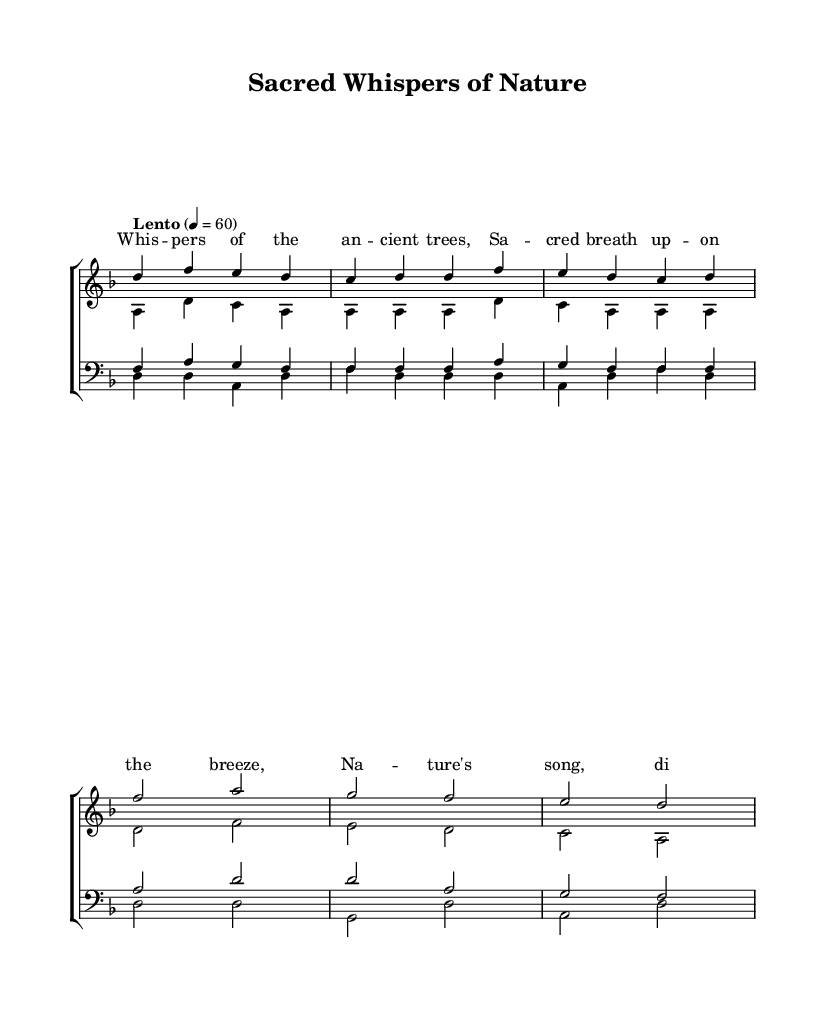What is the key signature of this music? The key signature is indicated at the beginning of the piece as D minor, which has one flat.
Answer: D minor What is the time signature of this music? The time signature is located at the beginning, depicted as 4/4, which means there are four beats in each measure.
Answer: 4/4 What is the tempo marking for this piece? The tempo marking is found near the beginning as "Lento," which signifies a slow pace, with a metronome indication of 60 beats per minute.
Answer: Lento How many parts are there in this choir arrangement? By examining the score, there are four main vocal parts: sopranos, altos, tenors, and basses, which create a rich choral texture.
Answer: Four What words are sung in the chorus section? The words for the chorus are visually discernible in the lyrics section aligned with the chorus melody, which states "Nature's song, divine and free."
Answer: Nature's song, divine and free Which musical element blends with the choral components in this piece? The sheet music indicates that natural sounds blend with the choral elements, providing a reflective and immersive atmosphere outlined in the title and lyrics.
Answer: Natural sounds What mood or feeling does the piece aim to convey? Analyzing the dynamics and tempo, alongside the serene lyrics, the music evokes a meditative and peaceful mood, aligned with its religious theme.
Answer: Meditative 